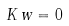Convert formula to latex. <formula><loc_0><loc_0><loc_500><loc_500>K \, w = 0</formula> 